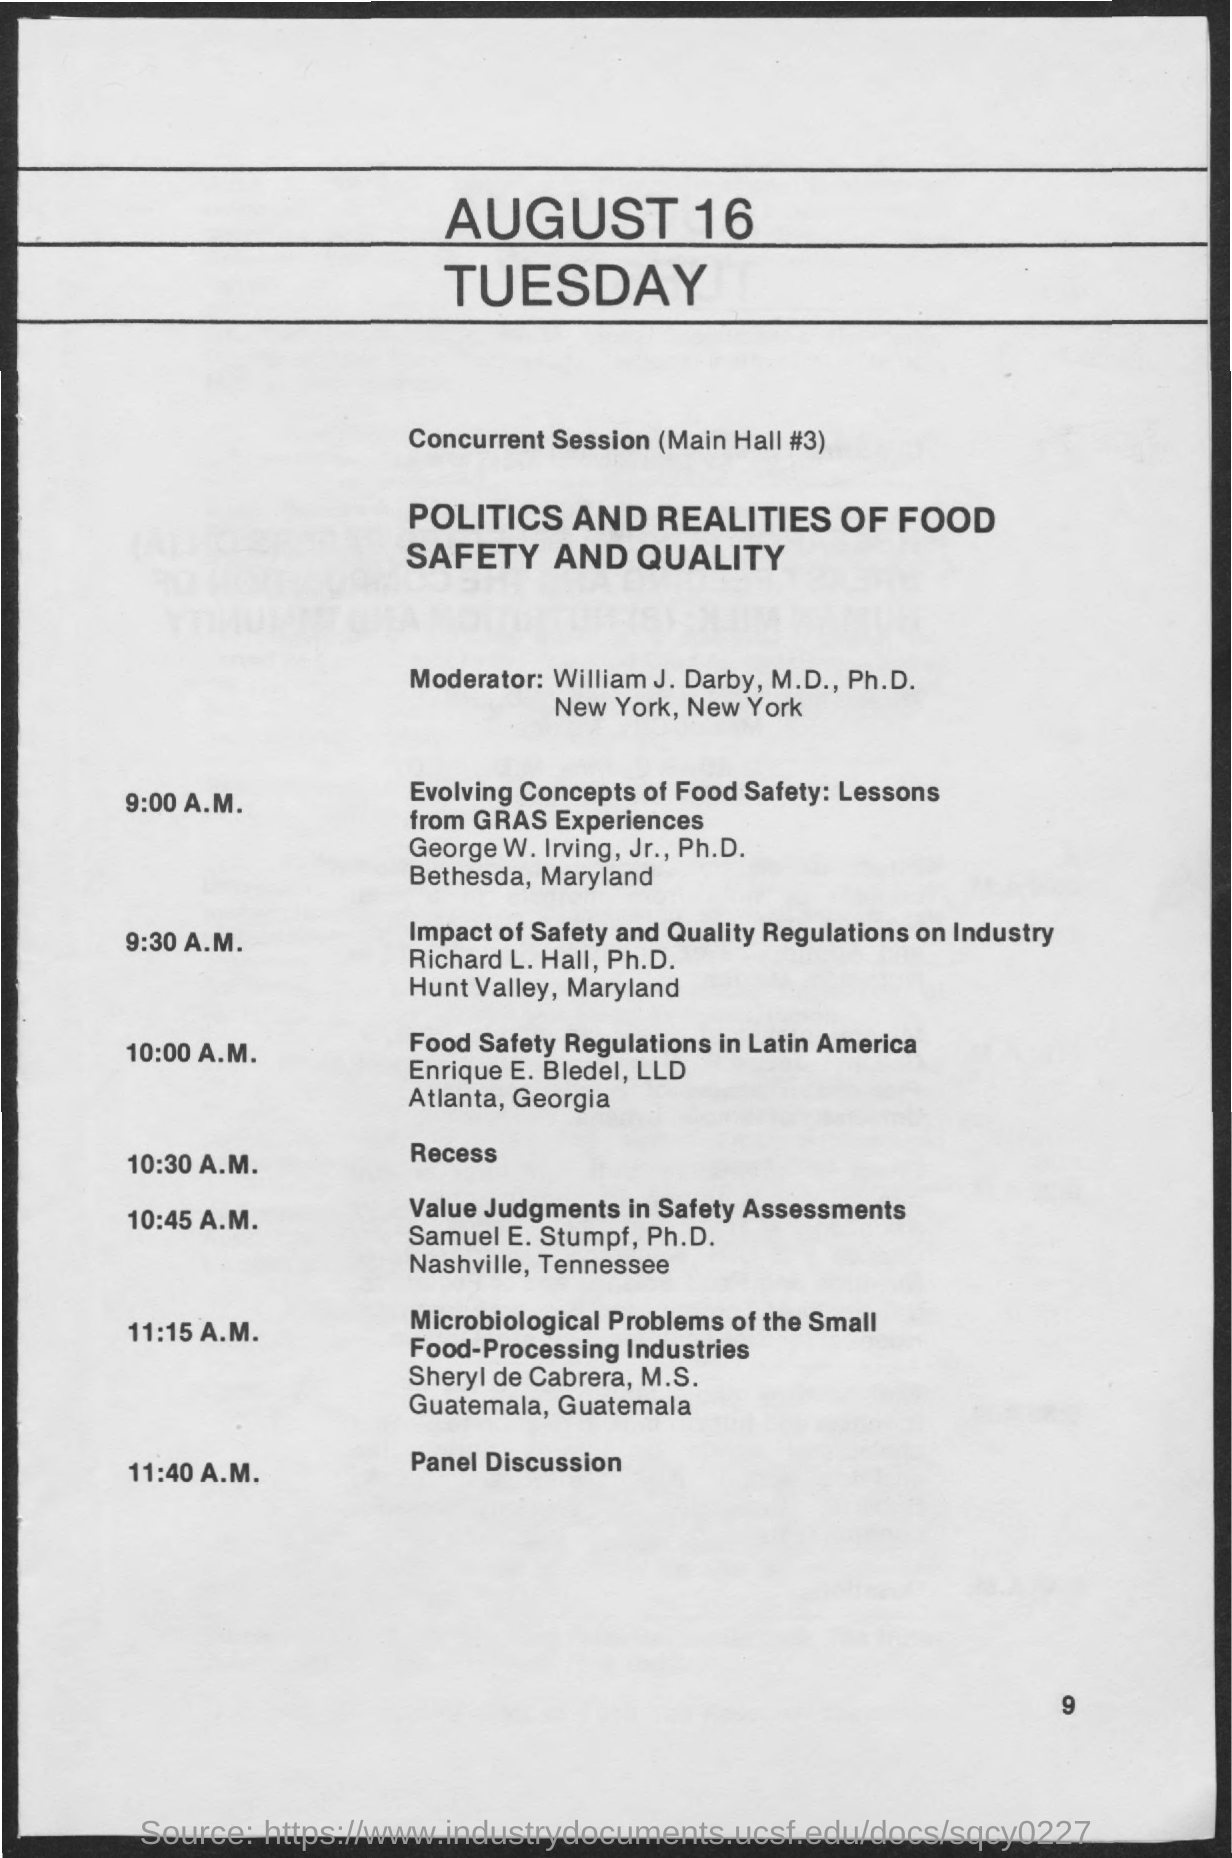What is the date mentioned in the given page ?
Your response must be concise. August 16 tuesday. What is the name of the moderator mentioned in the given page ?
Offer a very short reply. William J. Darby. What is the schedule at the time of 10:30 a.m. ?
Provide a short and direct response. Recess. What is the schedule at the time of 11:40 a.m. ?
Offer a very short reply. Panel discussion. What is the title for the topic of concurrent session as mentioned in the given page ?
Your answer should be compact. Politics and realities of food safety and quality. 